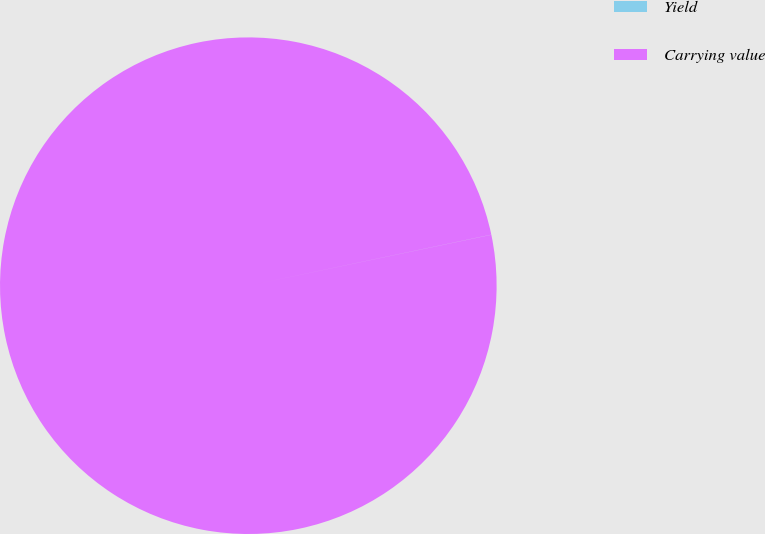Convert chart to OTSL. <chart><loc_0><loc_0><loc_500><loc_500><pie_chart><fcel>Yield<fcel>Carrying value<nl><fcel>0.01%<fcel>99.99%<nl></chart> 